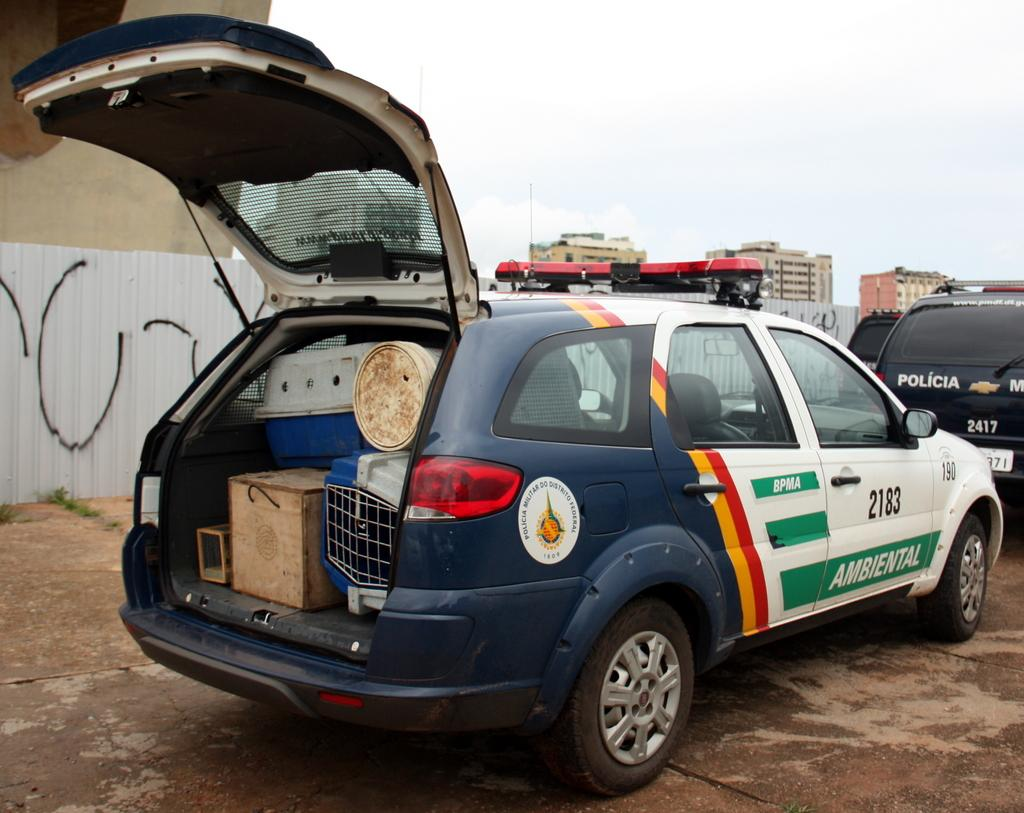What types of vehicles can be seen in the image? There are vehicles in the image, but the specific types cannot be determined from the provided facts. What is the box used for in the image? The purpose of the box in the image cannot be determined from the provided facts. What other objects are present in the image besides vehicles and the box? There are other objects in the image, but their specific nature cannot be determined from the provided facts. What is the purpose of the footpath in the image? The purpose of the footpath in the image cannot be determined from the provided facts. What types of buildings are visible in the image? There are buildings in the image, but their specific types cannot be determined from the provided facts. What is visible in the sky in the image? The sky is visible in the image, but the specific conditions or features cannot be determined from the provided facts. How much salt is sprinkled on the ground in the image? There is no salt present in the image, and therefore no salt can be sprinkled on the ground. 